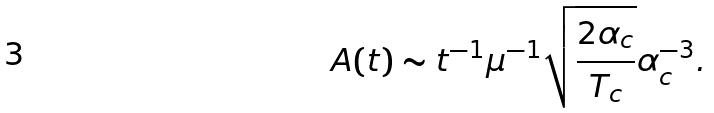Convert formula to latex. <formula><loc_0><loc_0><loc_500><loc_500>A ( t ) \sim t ^ { - 1 } \mu ^ { - 1 } \sqrt { \frac { 2 \alpha _ { c } } { T _ { c } } } \alpha _ { c } ^ { - 3 } .</formula> 